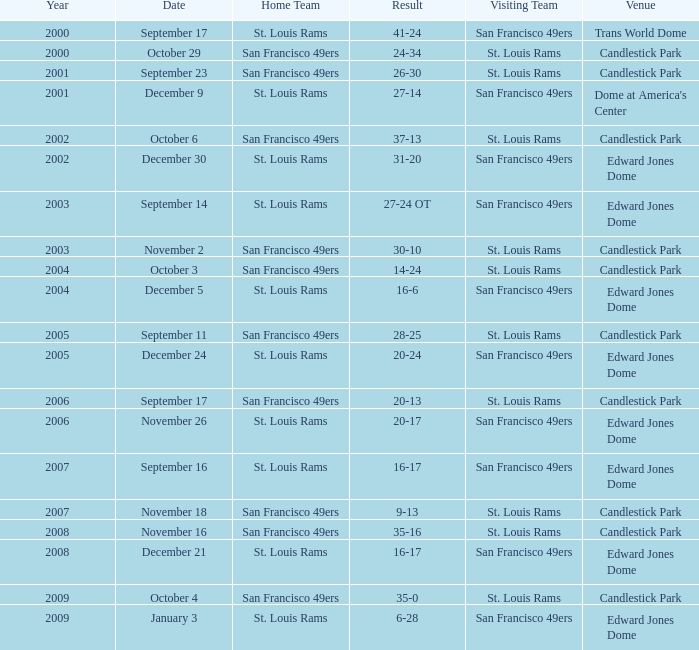What was the Venue on November 26? Edward Jones Dome. 